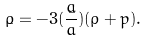<formula> <loc_0><loc_0><loc_500><loc_500>\dot { \rho } = - 3 ( \frac { \dot { a } } { a } ) ( \rho + p ) .</formula> 